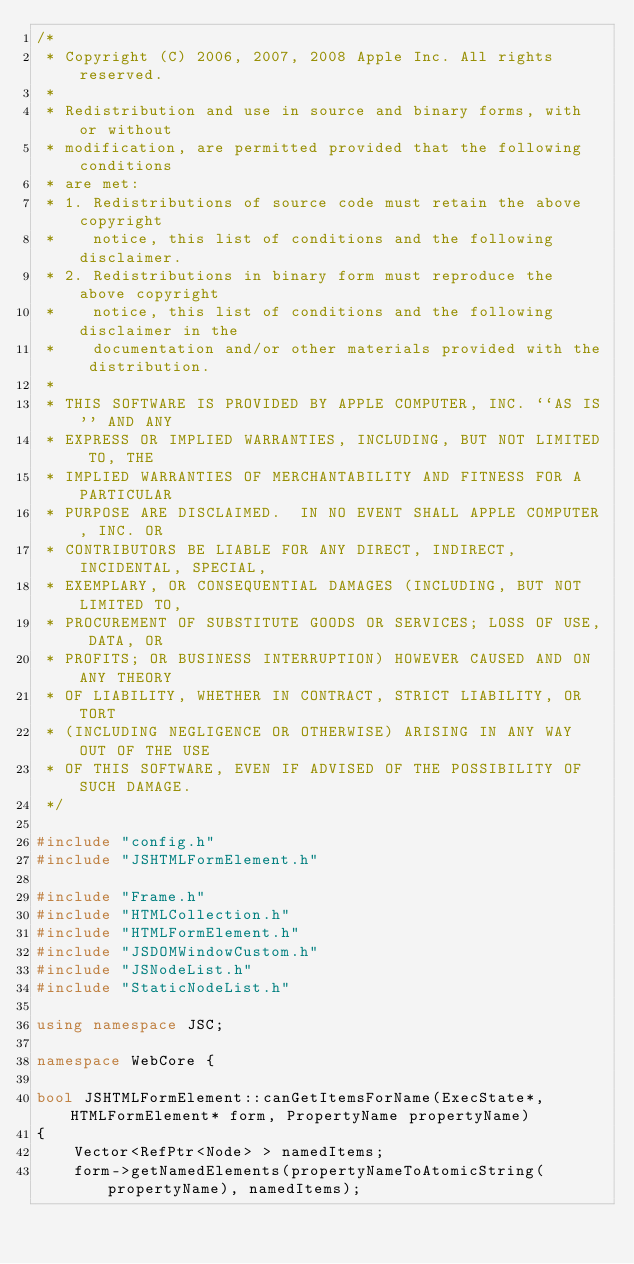Convert code to text. <code><loc_0><loc_0><loc_500><loc_500><_C++_>/*
 * Copyright (C) 2006, 2007, 2008 Apple Inc. All rights reserved.
 *
 * Redistribution and use in source and binary forms, with or without
 * modification, are permitted provided that the following conditions
 * are met:
 * 1. Redistributions of source code must retain the above copyright
 *    notice, this list of conditions and the following disclaimer.
 * 2. Redistributions in binary form must reproduce the above copyright
 *    notice, this list of conditions and the following disclaimer in the
 *    documentation and/or other materials provided with the distribution.
 *
 * THIS SOFTWARE IS PROVIDED BY APPLE COMPUTER, INC. ``AS IS'' AND ANY
 * EXPRESS OR IMPLIED WARRANTIES, INCLUDING, BUT NOT LIMITED TO, THE
 * IMPLIED WARRANTIES OF MERCHANTABILITY AND FITNESS FOR A PARTICULAR
 * PURPOSE ARE DISCLAIMED.  IN NO EVENT SHALL APPLE COMPUTER, INC. OR
 * CONTRIBUTORS BE LIABLE FOR ANY DIRECT, INDIRECT, INCIDENTAL, SPECIAL,
 * EXEMPLARY, OR CONSEQUENTIAL DAMAGES (INCLUDING, BUT NOT LIMITED TO,
 * PROCUREMENT OF SUBSTITUTE GOODS OR SERVICES; LOSS OF USE, DATA, OR
 * PROFITS; OR BUSINESS INTERRUPTION) HOWEVER CAUSED AND ON ANY THEORY
 * OF LIABILITY, WHETHER IN CONTRACT, STRICT LIABILITY, OR TORT
 * (INCLUDING NEGLIGENCE OR OTHERWISE) ARISING IN ANY WAY OUT OF THE USE
 * OF THIS SOFTWARE, EVEN IF ADVISED OF THE POSSIBILITY OF SUCH DAMAGE. 
 */

#include "config.h"
#include "JSHTMLFormElement.h"

#include "Frame.h"
#include "HTMLCollection.h"
#include "HTMLFormElement.h"
#include "JSDOMWindowCustom.h"
#include "JSNodeList.h"
#include "StaticNodeList.h"

using namespace JSC;

namespace WebCore {

bool JSHTMLFormElement::canGetItemsForName(ExecState*, HTMLFormElement* form, PropertyName propertyName)
{
    Vector<RefPtr<Node> > namedItems;
    form->getNamedElements(propertyNameToAtomicString(propertyName), namedItems);</code> 